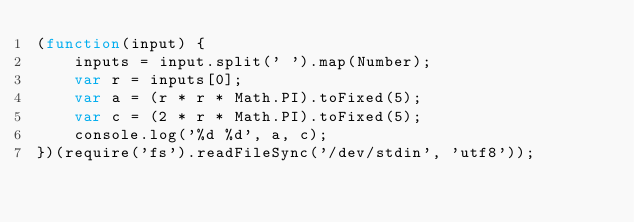<code> <loc_0><loc_0><loc_500><loc_500><_JavaScript_>(function(input) {
    inputs = input.split(' ').map(Number);
    var r = inputs[0];
    var a = (r * r * Math.PI).toFixed(5);
    var c = (2 * r * Math.PI).toFixed(5);
    console.log('%d %d', a, c);
})(require('fs').readFileSync('/dev/stdin', 'utf8'));</code> 